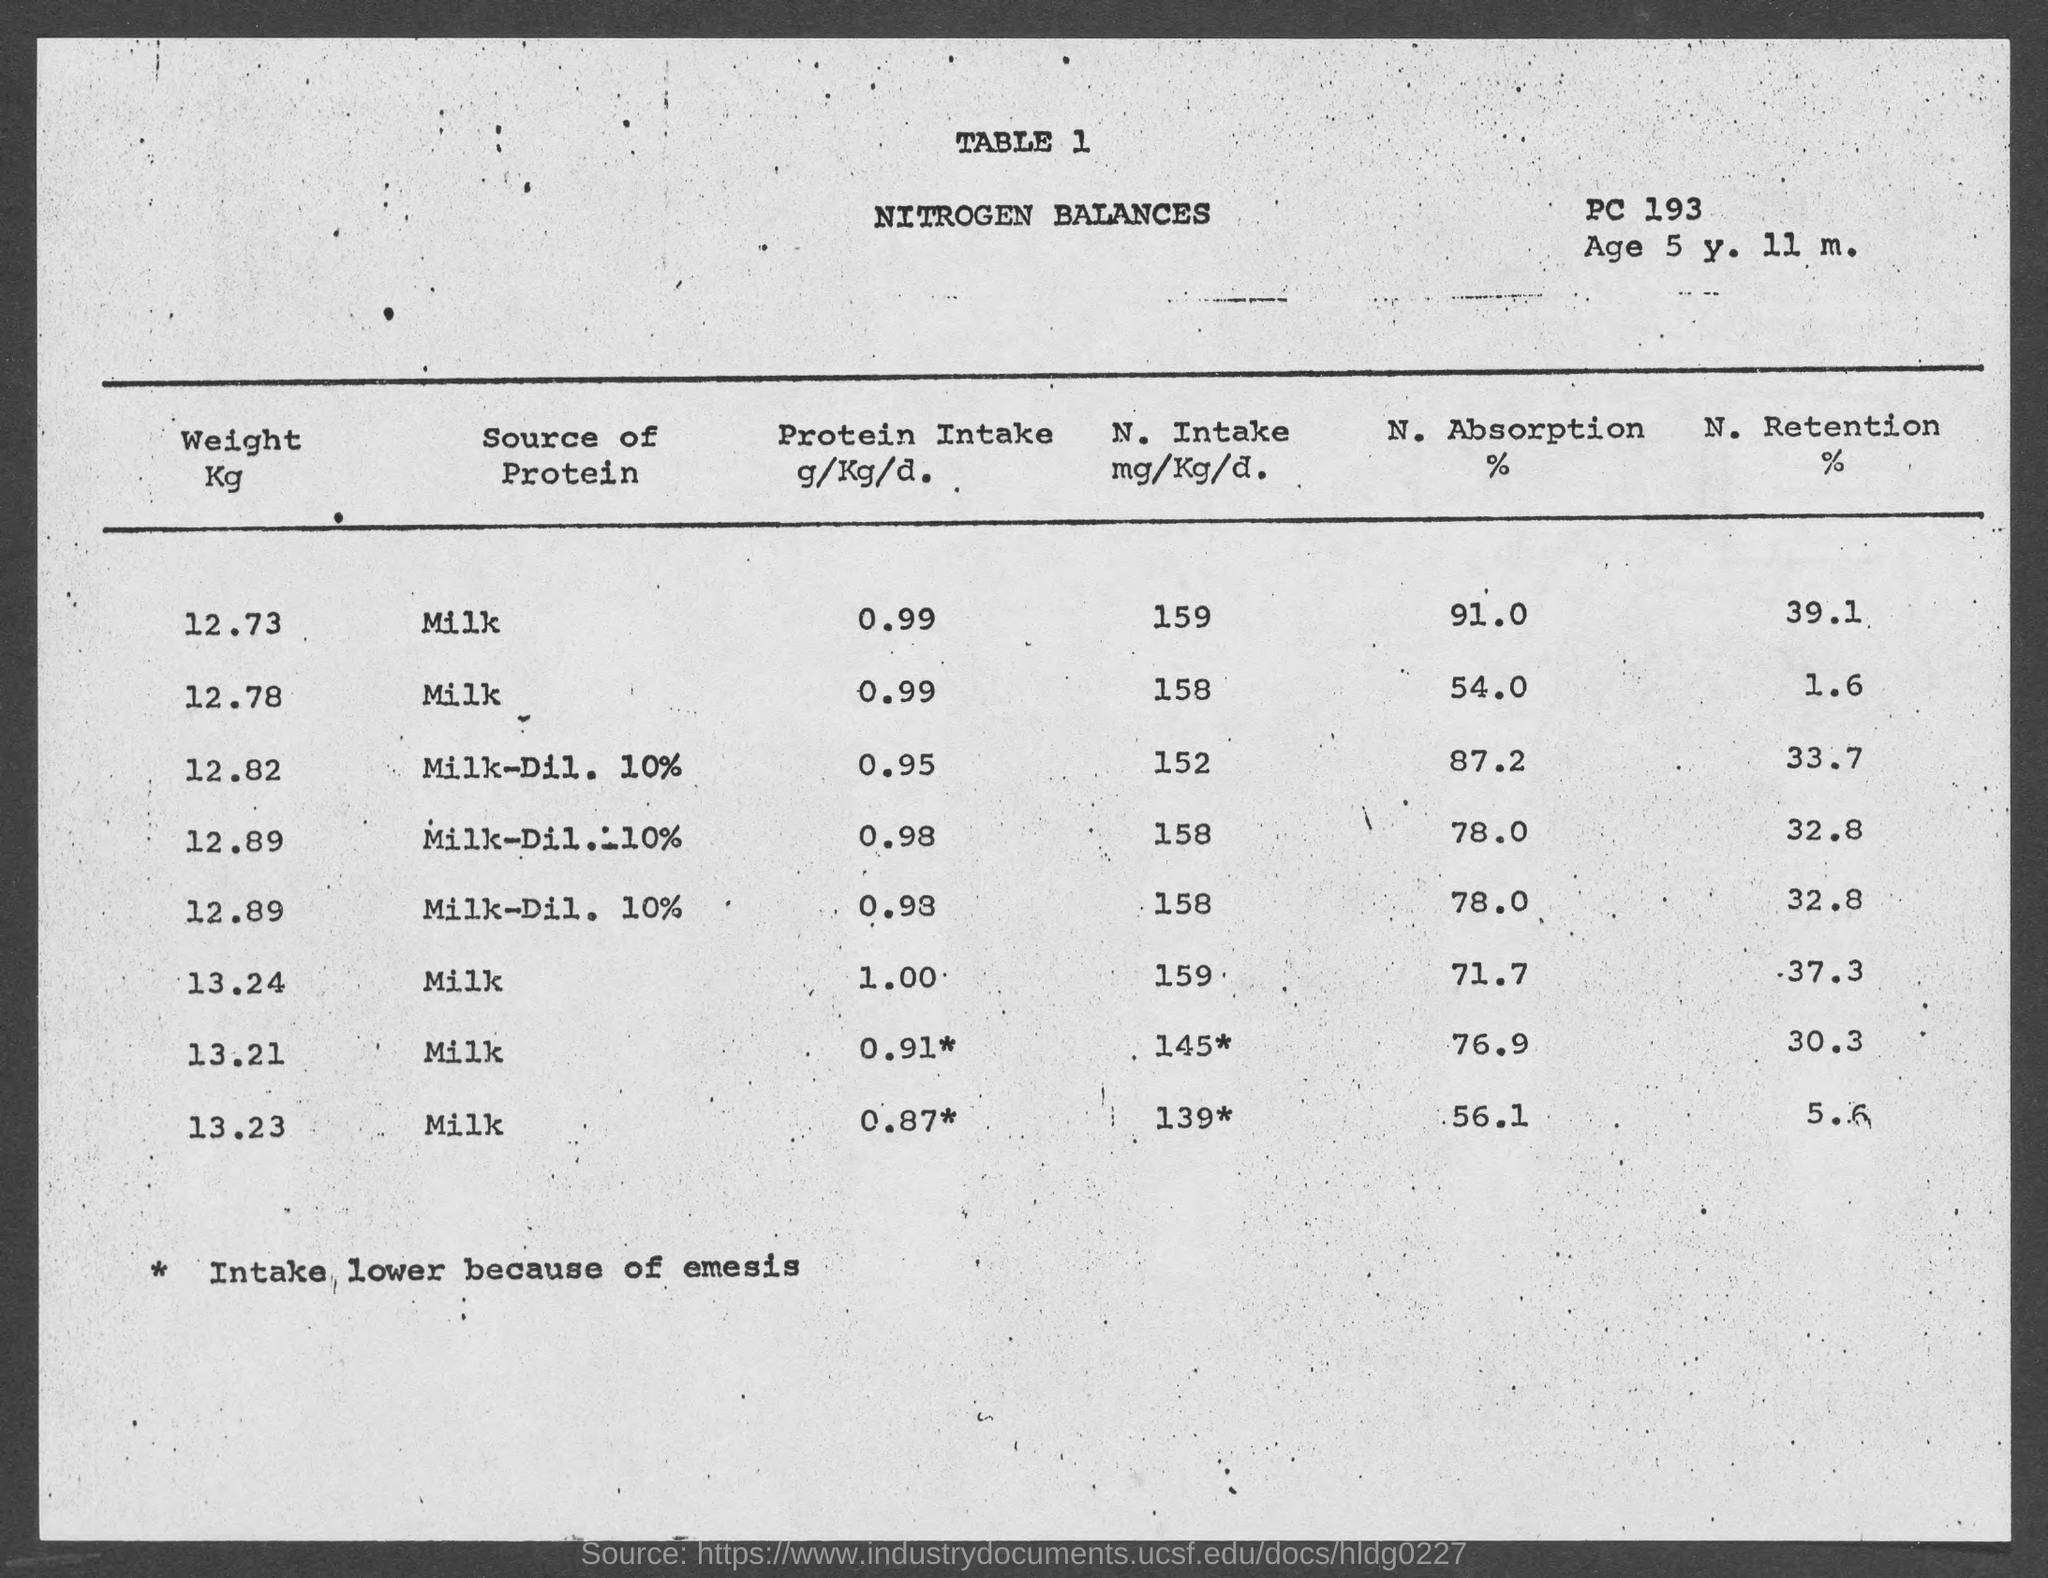What is the table number?
Provide a succinct answer. 1. What is the title of the table?
Your answer should be very brief. Nitrogen Balances. What is the age mentioned in the document?
Your response must be concise. Age 5 y. 11 m. What percentage of nitrogen is absorbed by the child with weight 12.73?
Provide a short and direct response. 91.0. What percentage of nitrogen is retained by the child with weight 12.73?
Make the answer very short. 39.1. What percentage of nitrogen is absorbed by the child with weight 13.23?
Give a very brief answer. 56.1. What percentage of nitrogen is retained by the child with weight 13.21?
Ensure brevity in your answer.  30.3. 